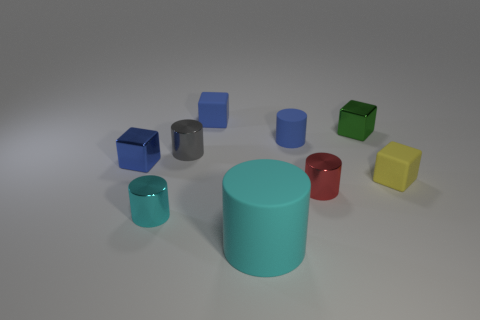What material is the other cylinder that is the same color as the large cylinder?
Your response must be concise. Metal. Are there any other things that have the same shape as the yellow thing?
Your response must be concise. Yes. What number of things are either small blue metallic things or gray metallic things?
Offer a terse response. 2. There is another blue thing that is the same shape as the small blue metal object; what size is it?
Ensure brevity in your answer.  Small. Are there any other things that are the same size as the yellow thing?
Provide a succinct answer. Yes. How many other objects are the same color as the big cylinder?
Give a very brief answer. 1. What number of cylinders are big blue rubber things or tiny metal objects?
Provide a short and direct response. 3. What color is the small rubber thing that is in front of the gray metal cylinder on the left side of the large cyan rubber cylinder?
Your answer should be compact. Yellow. What shape is the yellow object?
Your answer should be compact. Cube. There is a matte thing that is behind the green block; does it have the same size as the red metallic cylinder?
Your answer should be compact. Yes. 